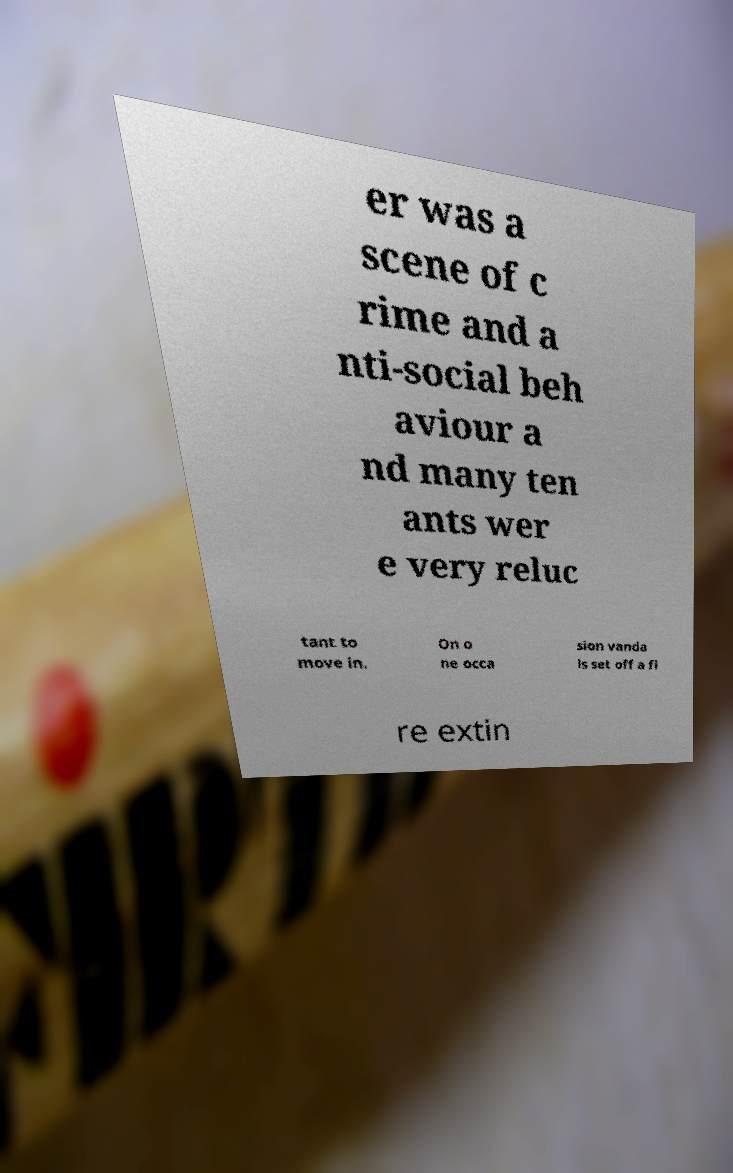For documentation purposes, I need the text within this image transcribed. Could you provide that? er was a scene of c rime and a nti-social beh aviour a nd many ten ants wer e very reluc tant to move in. On o ne occa sion vanda ls set off a fi re extin 